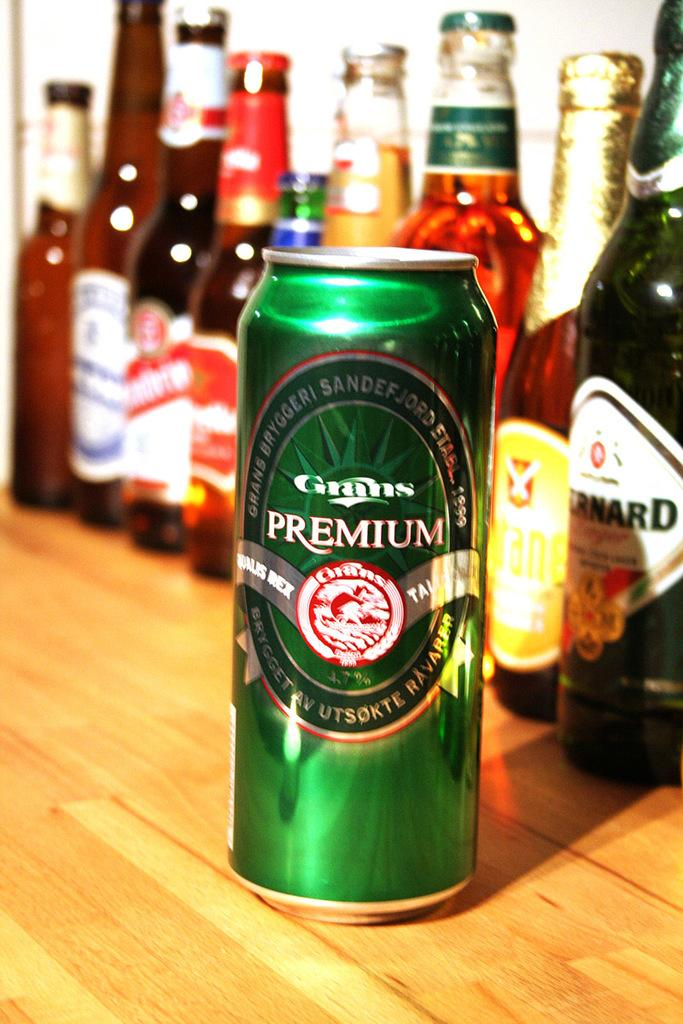<image>
Write a terse but informative summary of the picture. Tall and green Grans Premium beer in front of other beer bottles. 